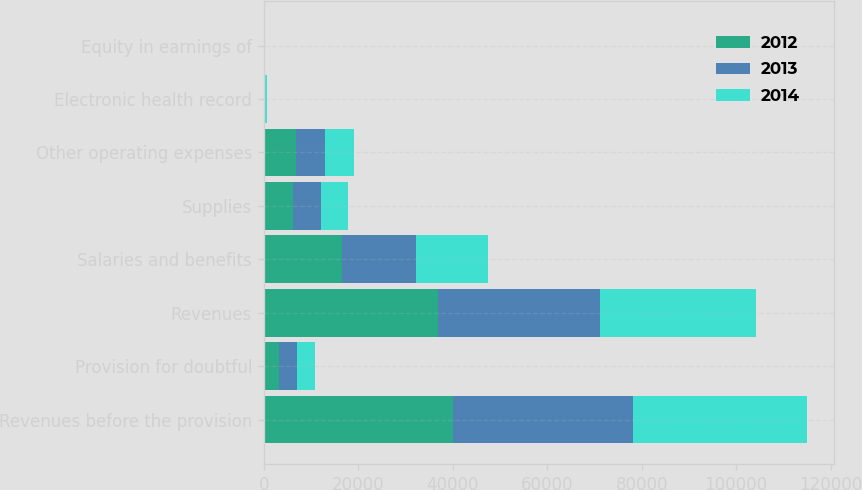Convert chart to OTSL. <chart><loc_0><loc_0><loc_500><loc_500><stacked_bar_chart><ecel><fcel>Revenues before the provision<fcel>Provision for doubtful<fcel>Revenues<fcel>Salaries and benefits<fcel>Supplies<fcel>Other operating expenses<fcel>Electronic health record<fcel>Equity in earnings of<nl><fcel>2012<fcel>40087<fcel>3169<fcel>36918<fcel>16641<fcel>6262<fcel>6755<fcel>125<fcel>43<nl><fcel>2013<fcel>38040<fcel>3858<fcel>34182<fcel>15646<fcel>5970<fcel>6237<fcel>216<fcel>29<nl><fcel>2014<fcel>36783<fcel>3770<fcel>33013<fcel>15089<fcel>5717<fcel>6048<fcel>336<fcel>36<nl></chart> 